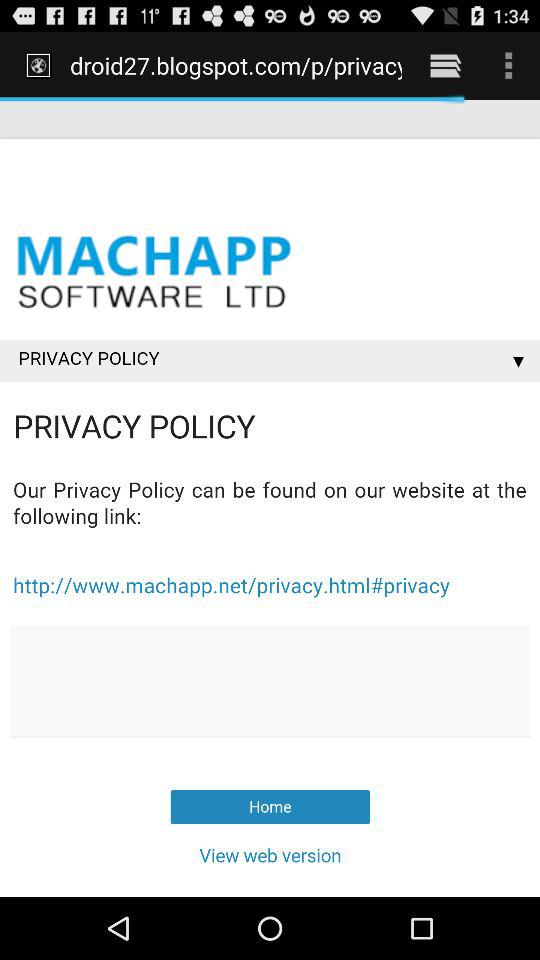What is the application name? The application name is "MACHAPP SOFTWARE LTD". 